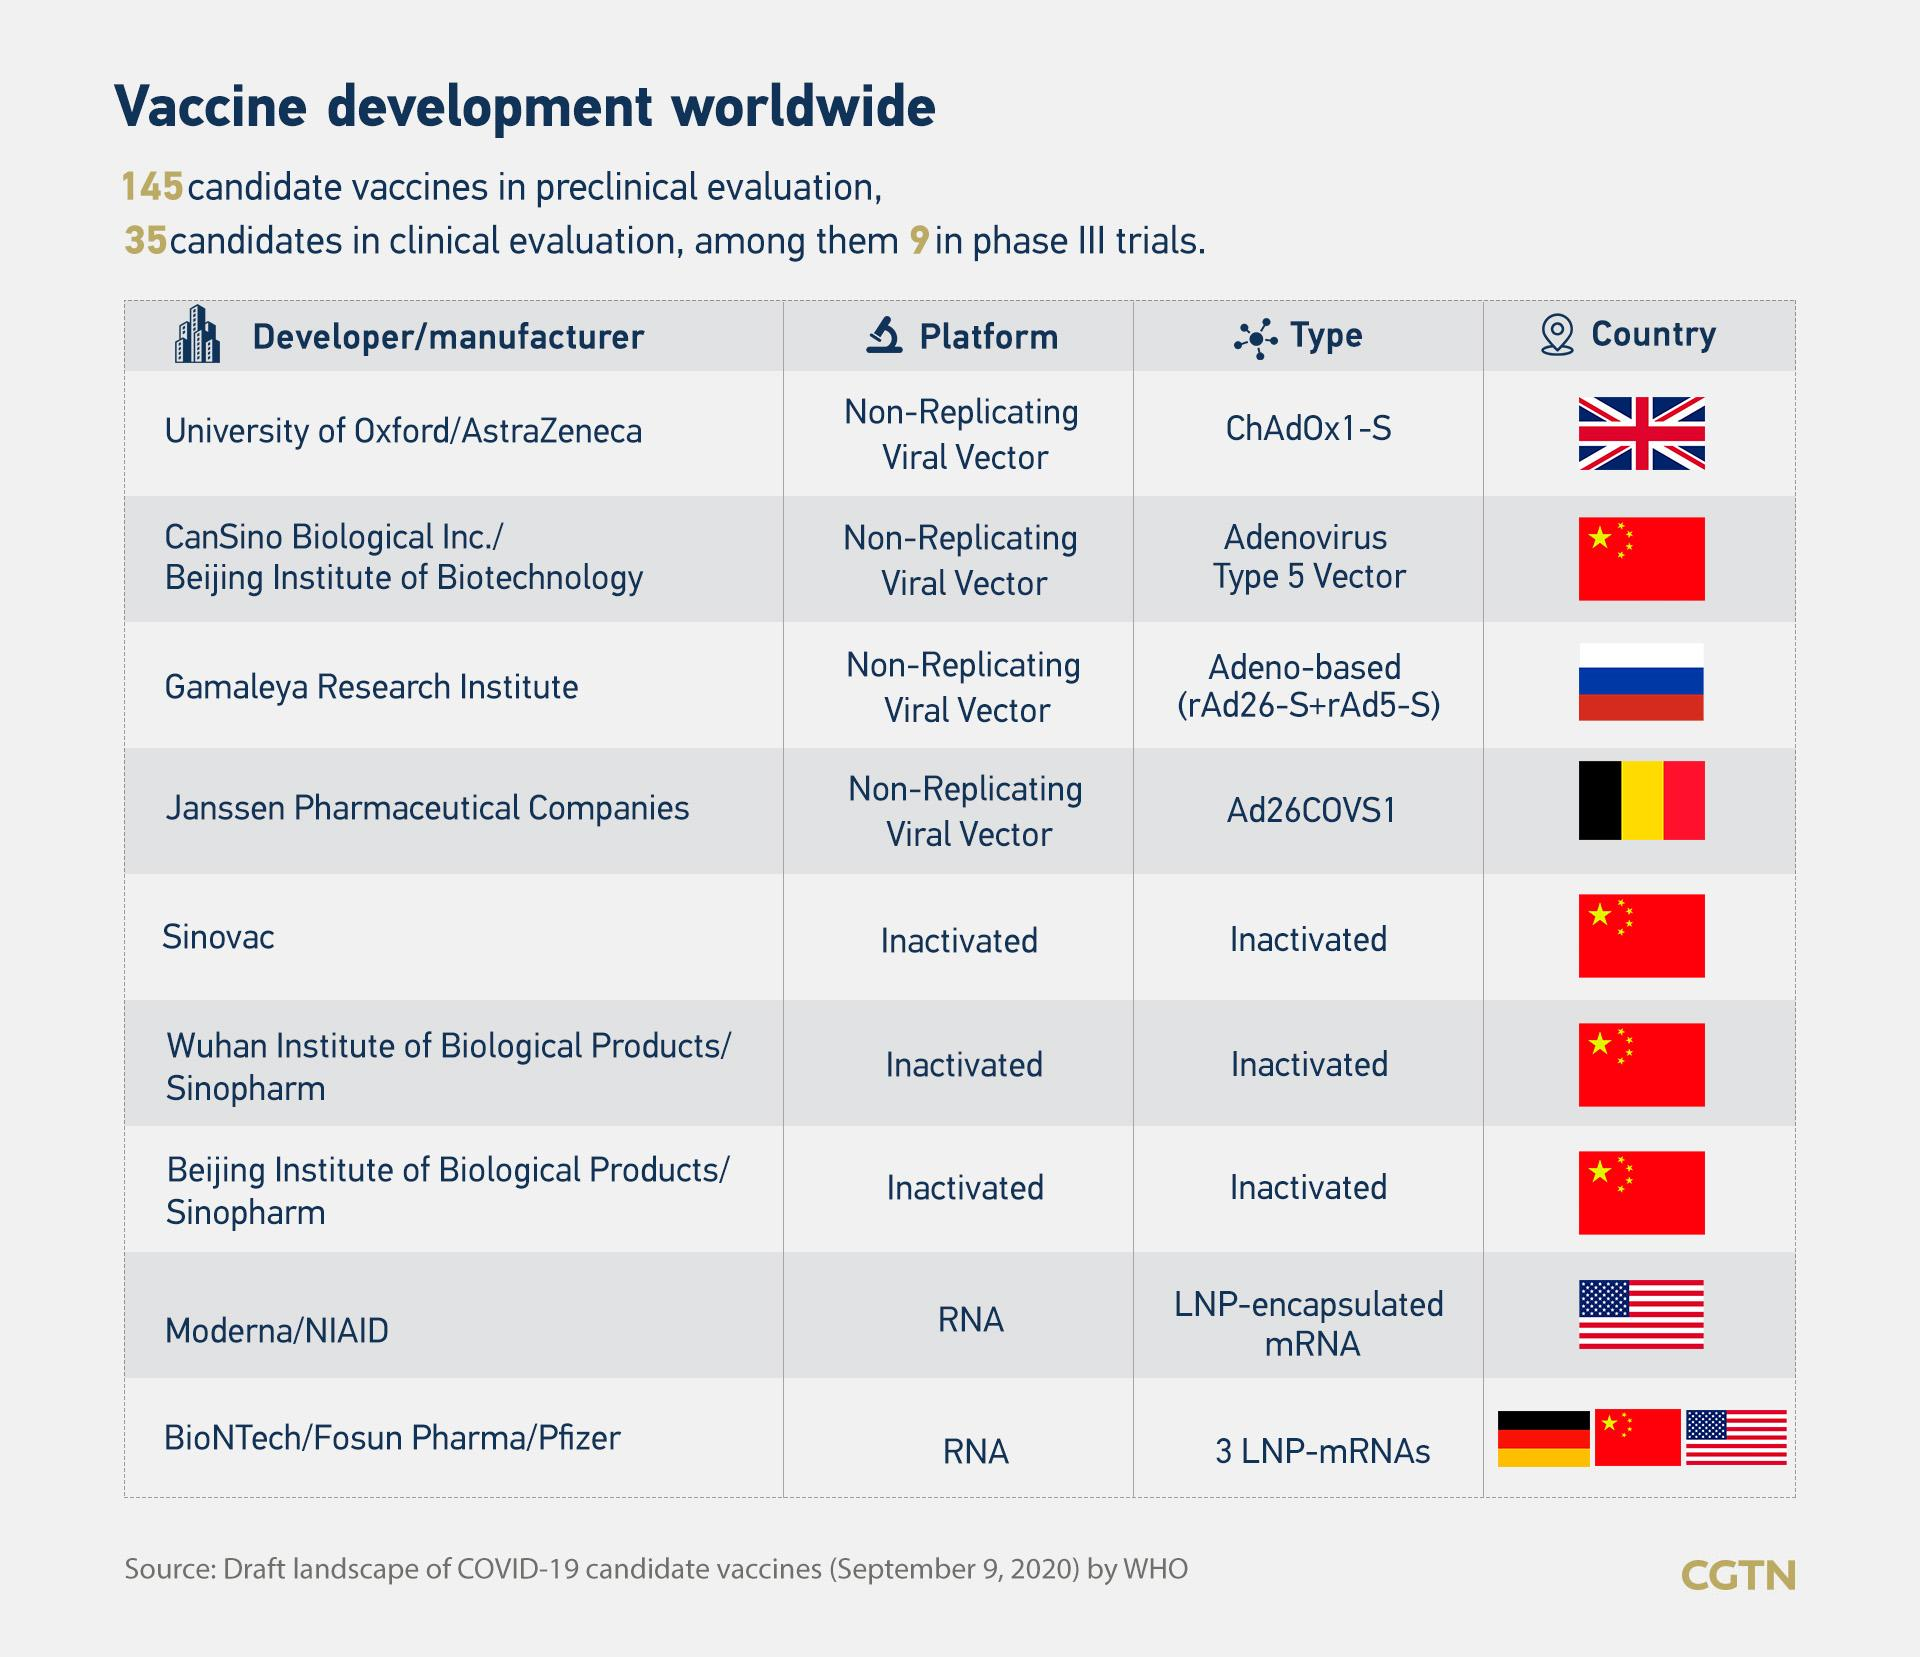Give some essential details in this illustration. Of the vaccines available, 3 are of the inactivated type. It has been listed that 9 developers have been identified. A vaccine called ChAdOx1-S is currently being developed in the United Kingdom. Two vaccines currently utilize an RNA platform. The manufacturer of a LNP-encapsulated mRNA type vaccine is developing it in either China, the UK, or the USA. The USA is developing it. 